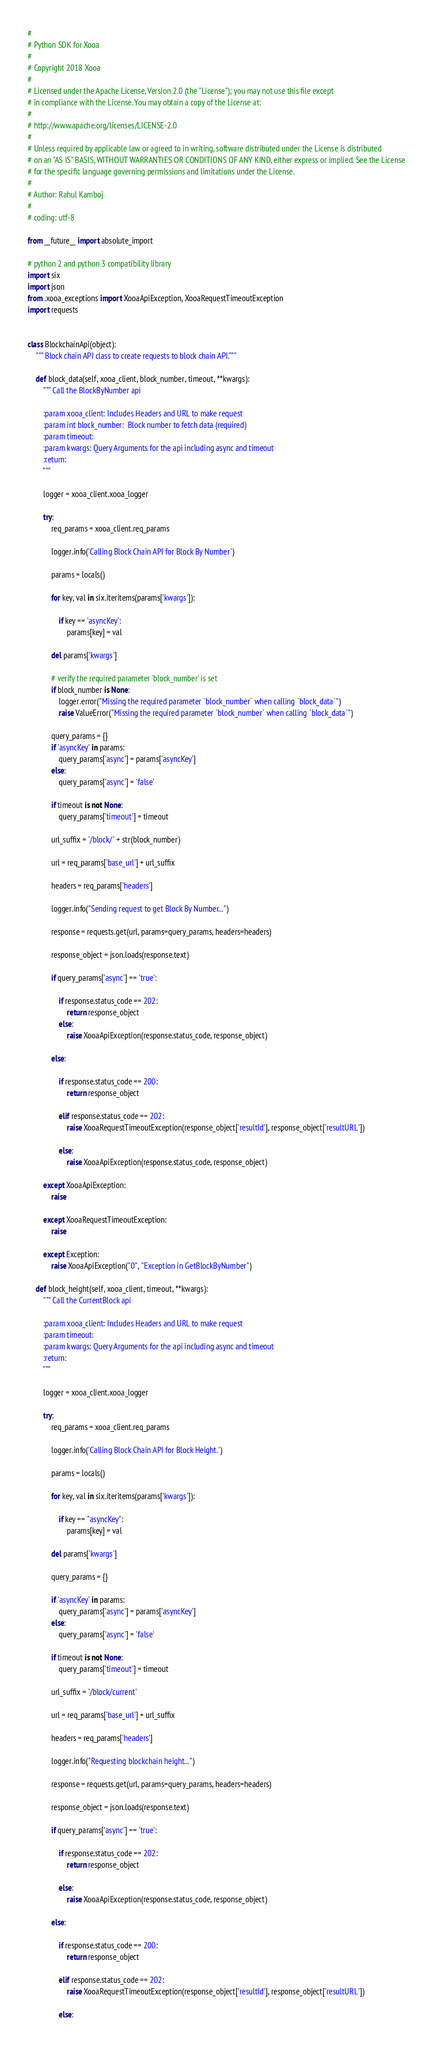<code> <loc_0><loc_0><loc_500><loc_500><_Python_>#
# Python SDK for Xooa
#
# Copyright 2018 Xooa
#
# Licensed under the Apache License, Version 2.0 (the "License"); you may not use this file except
# in compliance with the License. You may obtain a copy of the License at:
#
# http://www.apache.org/licenses/LICENSE-2.0
#
# Unless required by applicable law or agreed to in writing, software distributed under the License is distributed
# on an "AS IS" BASIS, WITHOUT WARRANTIES OR CONDITIONS OF ANY KIND, either express or implied. See the License
# for the specific language governing permissions and limitations under the License.
#
# Author: Rahul Kamboj
#
# coding: utf-8

from __future__ import absolute_import

# python 2 and python 3 compatibility library
import six
import json
from .xooa_exceptions import XooaApiException, XooaRequestTimeoutException
import requests


class BlockchainApi(object):
    """ Block chain API class to create requests to block chain API."""

    def block_data(self, xooa_client, block_number, timeout, **kwargs):
        """ Call the BlockByNumber api

        :param xooa_client: Includes Headers and URL to make request
        :param int block_number:  Block number to fetch data (required)
        :param timeout:
        :param kwargs: Query Arguments for the api including async and timeout
        :return:
        """

        logger = xooa_client.xooa_logger

        try:
            req_params = xooa_client.req_params

            logger.info('Calling Block Chain API for Block By Number')

            params = locals()

            for key, val in six.iteritems(params['kwargs']):

                if key == 'asyncKey':
                    params[key] = val

            del params['kwargs']

            # verify the required parameter 'block_number' is set
            if block_number is None:
                logger.error("Missing the required parameter `block_number` when calling `block_data`")
                raise ValueError("Missing the required parameter `block_number` when calling `block_data`")

            query_params = {}
            if 'asyncKey' in params:
                query_params['async'] = params['asyncKey']
            else:
                query_params['async'] = 'false'

            if timeout is not None:
                query_params['timeout'] = timeout

            url_suffix = '/block/' + str(block_number)

            url = req_params['base_url'] + url_suffix

            headers = req_params['headers']

            logger.info("Sending request to get Block By Number...")

            response = requests.get(url, params=query_params, headers=headers)

            response_object = json.loads(response.text)

            if query_params['async'] == 'true':

                if response.status_code == 202:
                    return response_object
                else:
                    raise XooaApiException(response.status_code, response_object)

            else:

                if response.status_code == 200:
                    return response_object

                elif response.status_code == 202:
                    raise XooaRequestTimeoutException(response_object['resultId'], response_object['resultURL'])

                else:
                    raise XooaApiException(response.status_code, response_object)

        except XooaApiException:
            raise

        except XooaRequestTimeoutException:
            raise

        except Exception:
            raise XooaApiException("0", "Exception in GetBlockByNumber")

    def block_height(self, xooa_client, timeout, **kwargs):
        """ Call the CurrentBlock api

        :param xooa_client: Includes Headers and URL to make request
        :param timeout:
        :param kwargs: Query Arguments for the api including async and timeout
        :return:
        """

        logger = xooa_client.xooa_logger

        try:
            req_params = xooa_client.req_params

            logger.info('Calling Block Chain API for Block Height.')

            params = locals()

            for key, val in six.iteritems(params['kwargs']):

                if key == "asyncKey":
                    params[key] = val

            del params['kwargs']

            query_params = {}

            if 'asyncKey' in params:
                query_params['async'] = params['asyncKey']
            else:
                query_params['async'] = 'false'

            if timeout is not None:
                query_params['timeout'] = timeout

            url_suffix = '/block/current'

            url = req_params['base_url'] + url_suffix

            headers = req_params['headers']

            logger.info("Requesting blockchain height...")

            response = requests.get(url, params=query_params, headers=headers)

            response_object = json.loads(response.text)

            if query_params['async'] == 'true':

                if response.status_code == 202:
                    return response_object

                else:
                    raise XooaApiException(response.status_code, response_object)

            else:

                if response.status_code == 200:
                    return response_object

                elif response.status_code == 202:
                    raise XooaRequestTimeoutException(response_object['resultId'], response_object['resultURL'])

                else:</code> 